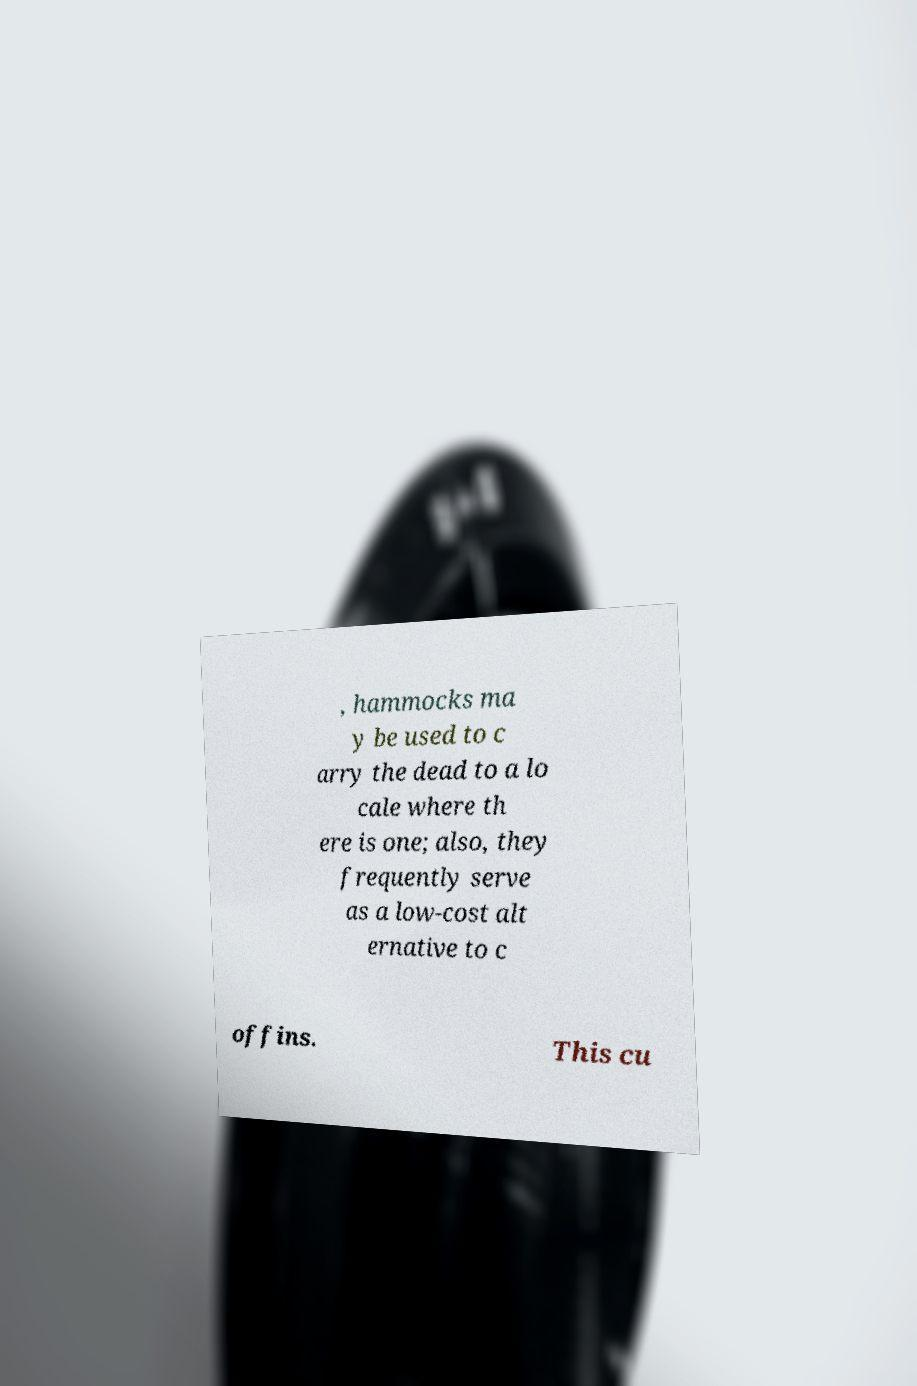What messages or text are displayed in this image? I need them in a readable, typed format. , hammocks ma y be used to c arry the dead to a lo cale where th ere is one; also, they frequently serve as a low-cost alt ernative to c offins. This cu 